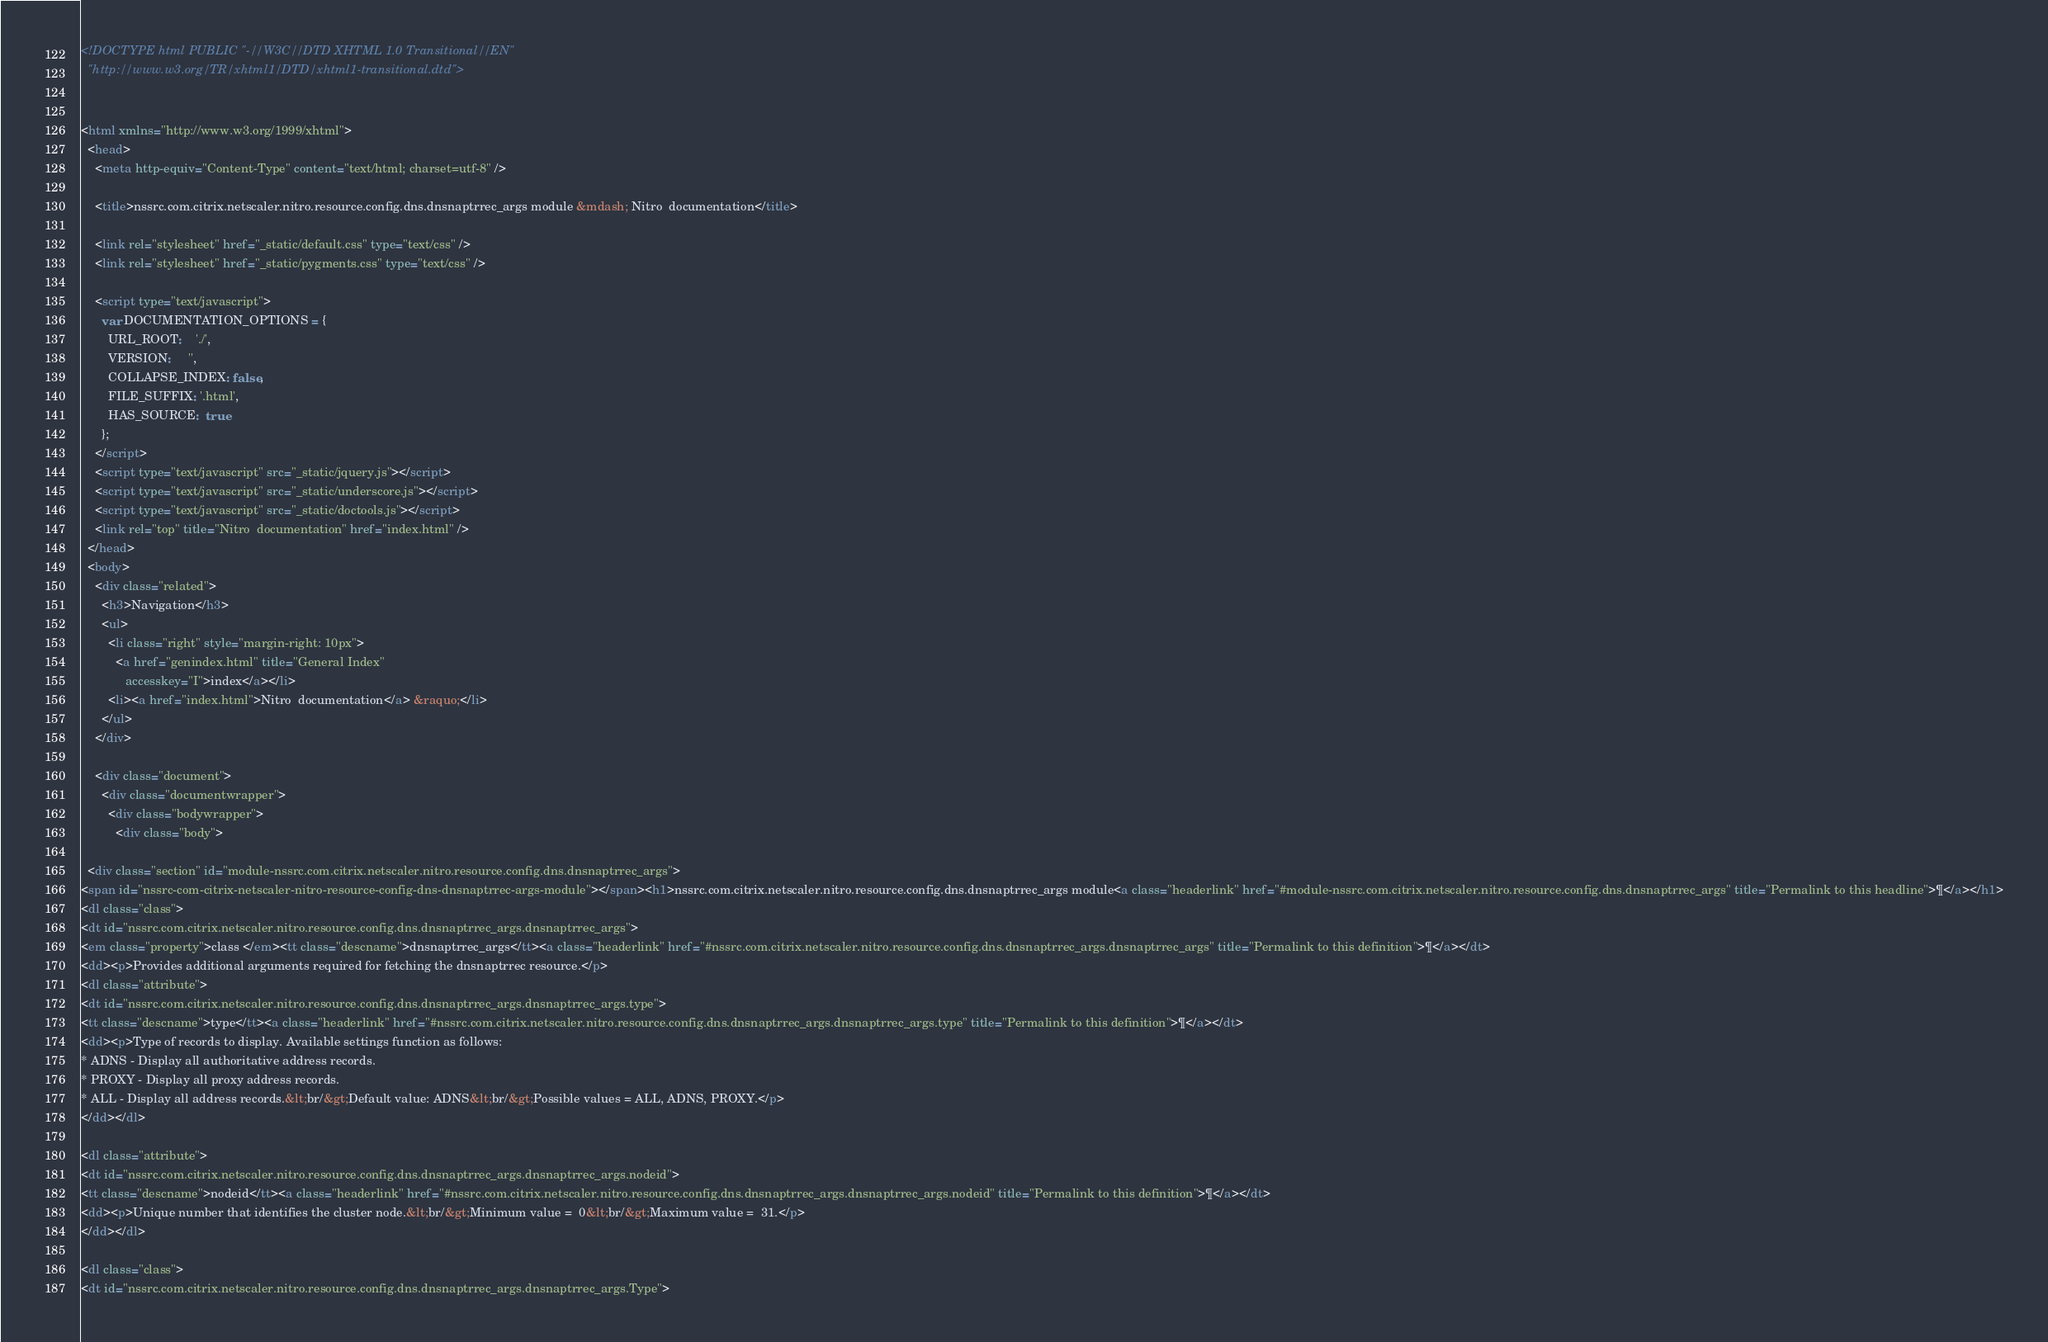<code> <loc_0><loc_0><loc_500><loc_500><_HTML_><!DOCTYPE html PUBLIC "-//W3C//DTD XHTML 1.0 Transitional//EN"
  "http://www.w3.org/TR/xhtml1/DTD/xhtml1-transitional.dtd">


<html xmlns="http://www.w3.org/1999/xhtml">
  <head>
    <meta http-equiv="Content-Type" content="text/html; charset=utf-8" />
    
    <title>nssrc.com.citrix.netscaler.nitro.resource.config.dns.dnsnaptrrec_args module &mdash; Nitro  documentation</title>
    
    <link rel="stylesheet" href="_static/default.css" type="text/css" />
    <link rel="stylesheet" href="_static/pygments.css" type="text/css" />
    
    <script type="text/javascript">
      var DOCUMENTATION_OPTIONS = {
        URL_ROOT:    './',
        VERSION:     '',
        COLLAPSE_INDEX: false,
        FILE_SUFFIX: '.html',
        HAS_SOURCE:  true
      };
    </script>
    <script type="text/javascript" src="_static/jquery.js"></script>
    <script type="text/javascript" src="_static/underscore.js"></script>
    <script type="text/javascript" src="_static/doctools.js"></script>
    <link rel="top" title="Nitro  documentation" href="index.html" /> 
  </head>
  <body>
    <div class="related">
      <h3>Navigation</h3>
      <ul>
        <li class="right" style="margin-right: 10px">
          <a href="genindex.html" title="General Index"
             accesskey="I">index</a></li>
        <li><a href="index.html">Nitro  documentation</a> &raquo;</li> 
      </ul>
    </div>  

    <div class="document">
      <div class="documentwrapper">
        <div class="bodywrapper">
          <div class="body">
            
  <div class="section" id="module-nssrc.com.citrix.netscaler.nitro.resource.config.dns.dnsnaptrrec_args">
<span id="nssrc-com-citrix-netscaler-nitro-resource-config-dns-dnsnaptrrec-args-module"></span><h1>nssrc.com.citrix.netscaler.nitro.resource.config.dns.dnsnaptrrec_args module<a class="headerlink" href="#module-nssrc.com.citrix.netscaler.nitro.resource.config.dns.dnsnaptrrec_args" title="Permalink to this headline">¶</a></h1>
<dl class="class">
<dt id="nssrc.com.citrix.netscaler.nitro.resource.config.dns.dnsnaptrrec_args.dnsnaptrrec_args">
<em class="property">class </em><tt class="descname">dnsnaptrrec_args</tt><a class="headerlink" href="#nssrc.com.citrix.netscaler.nitro.resource.config.dns.dnsnaptrrec_args.dnsnaptrrec_args" title="Permalink to this definition">¶</a></dt>
<dd><p>Provides additional arguments required for fetching the dnsnaptrrec resource.</p>
<dl class="attribute">
<dt id="nssrc.com.citrix.netscaler.nitro.resource.config.dns.dnsnaptrrec_args.dnsnaptrrec_args.type">
<tt class="descname">type</tt><a class="headerlink" href="#nssrc.com.citrix.netscaler.nitro.resource.config.dns.dnsnaptrrec_args.dnsnaptrrec_args.type" title="Permalink to this definition">¶</a></dt>
<dd><p>Type of records to display. Available settings function as follows:
* ADNS - Display all authoritative address records.
* PROXY - Display all proxy address records.
* ALL - Display all address records.&lt;br/&gt;Default value: ADNS&lt;br/&gt;Possible values = ALL, ADNS, PROXY.</p>
</dd></dl>

<dl class="attribute">
<dt id="nssrc.com.citrix.netscaler.nitro.resource.config.dns.dnsnaptrrec_args.dnsnaptrrec_args.nodeid">
<tt class="descname">nodeid</tt><a class="headerlink" href="#nssrc.com.citrix.netscaler.nitro.resource.config.dns.dnsnaptrrec_args.dnsnaptrrec_args.nodeid" title="Permalink to this definition">¶</a></dt>
<dd><p>Unique number that identifies the cluster node.&lt;br/&gt;Minimum value =  0&lt;br/&gt;Maximum value =  31.</p>
</dd></dl>

<dl class="class">
<dt id="nssrc.com.citrix.netscaler.nitro.resource.config.dns.dnsnaptrrec_args.dnsnaptrrec_args.Type"></code> 